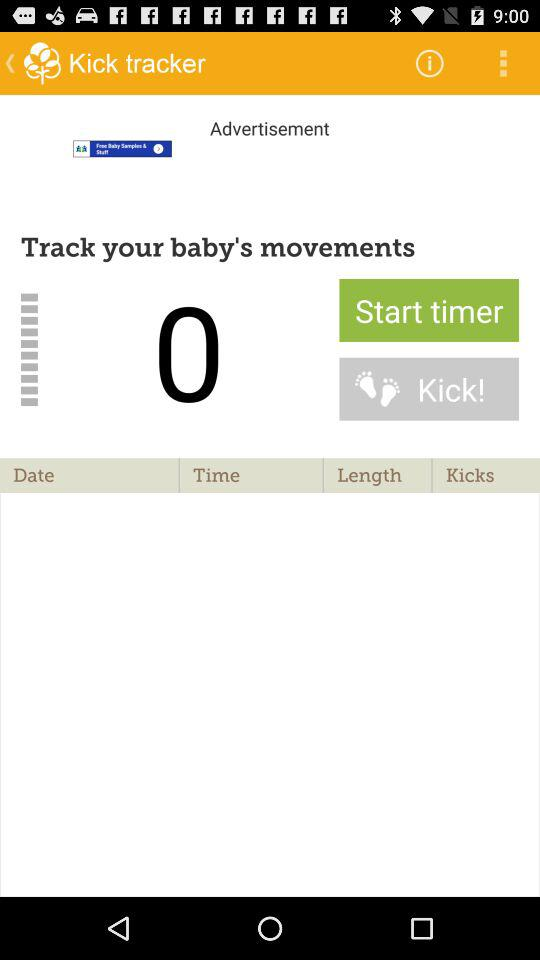What is the name of the application? The name of the application is "Kick tracker". 